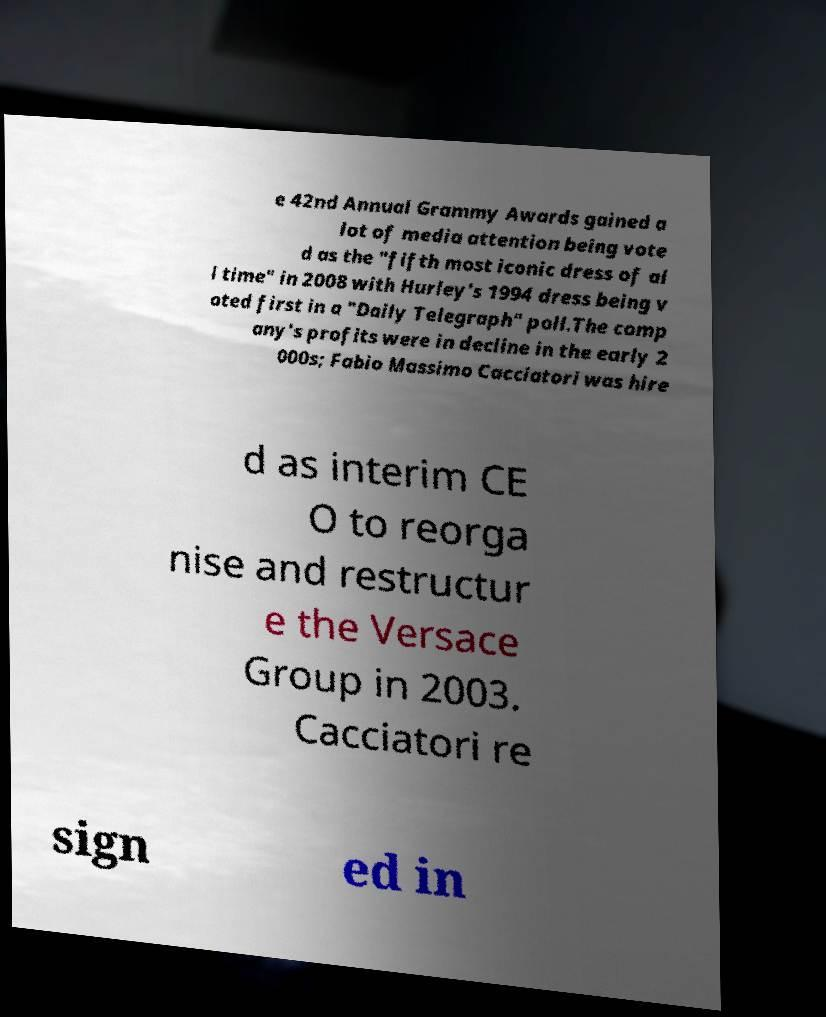Could you assist in decoding the text presented in this image and type it out clearly? e 42nd Annual Grammy Awards gained a lot of media attention being vote d as the "fifth most iconic dress of al l time" in 2008 with Hurley's 1994 dress being v oted first in a "Daily Telegraph" poll.The comp any's profits were in decline in the early 2 000s; Fabio Massimo Cacciatori was hire d as interim CE O to reorga nise and restructur e the Versace Group in 2003. Cacciatori re sign ed in 